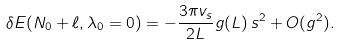<formula> <loc_0><loc_0><loc_500><loc_500>\delta E ( N _ { 0 } + \ell , \lambda _ { 0 } = 0 ) = - \frac { 3 \pi v _ { s } } { 2 L } g ( L ) \, s ^ { 2 } + O ( g ^ { 2 } ) .</formula> 